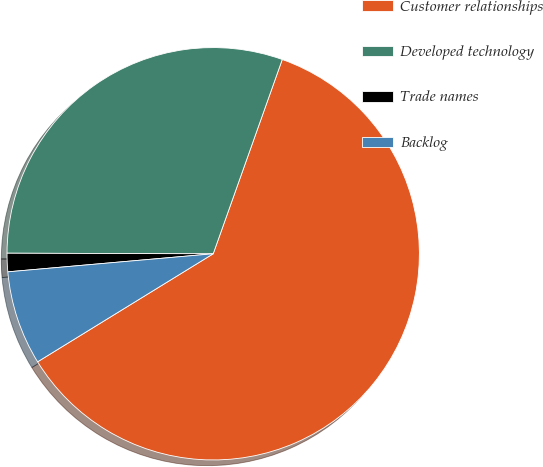<chart> <loc_0><loc_0><loc_500><loc_500><pie_chart><fcel>Customer relationships<fcel>Developed technology<fcel>Trade names<fcel>Backlog<nl><fcel>60.78%<fcel>30.39%<fcel>1.44%<fcel>7.38%<nl></chart> 